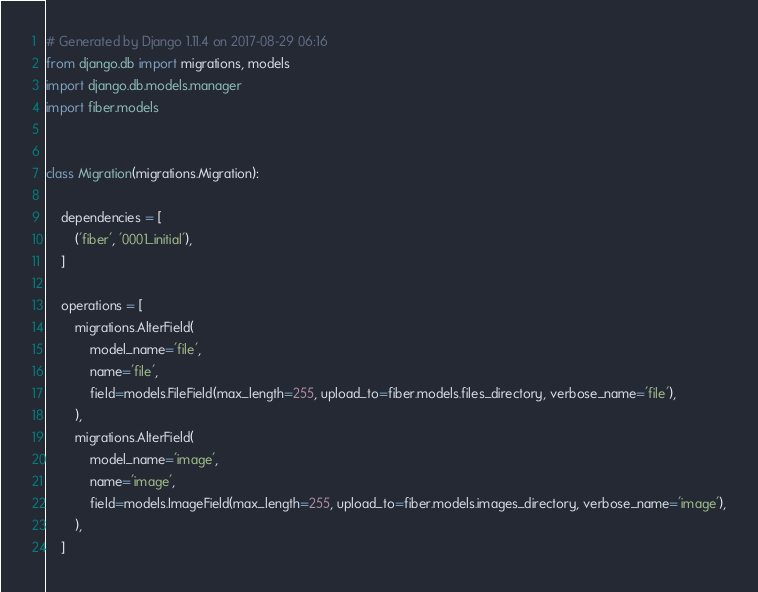Convert code to text. <code><loc_0><loc_0><loc_500><loc_500><_Python_># Generated by Django 1.11.4 on 2017-08-29 06:16
from django.db import migrations, models
import django.db.models.manager
import fiber.models


class Migration(migrations.Migration):

    dependencies = [
        ('fiber', '0001_initial'),
    ]

    operations = [
        migrations.AlterField(
            model_name='file',
            name='file',
            field=models.FileField(max_length=255, upload_to=fiber.models.files_directory, verbose_name='file'),
        ),
        migrations.AlterField(
            model_name='image',
            name='image',
            field=models.ImageField(max_length=255, upload_to=fiber.models.images_directory, verbose_name='image'),
        ),
    ]
</code> 